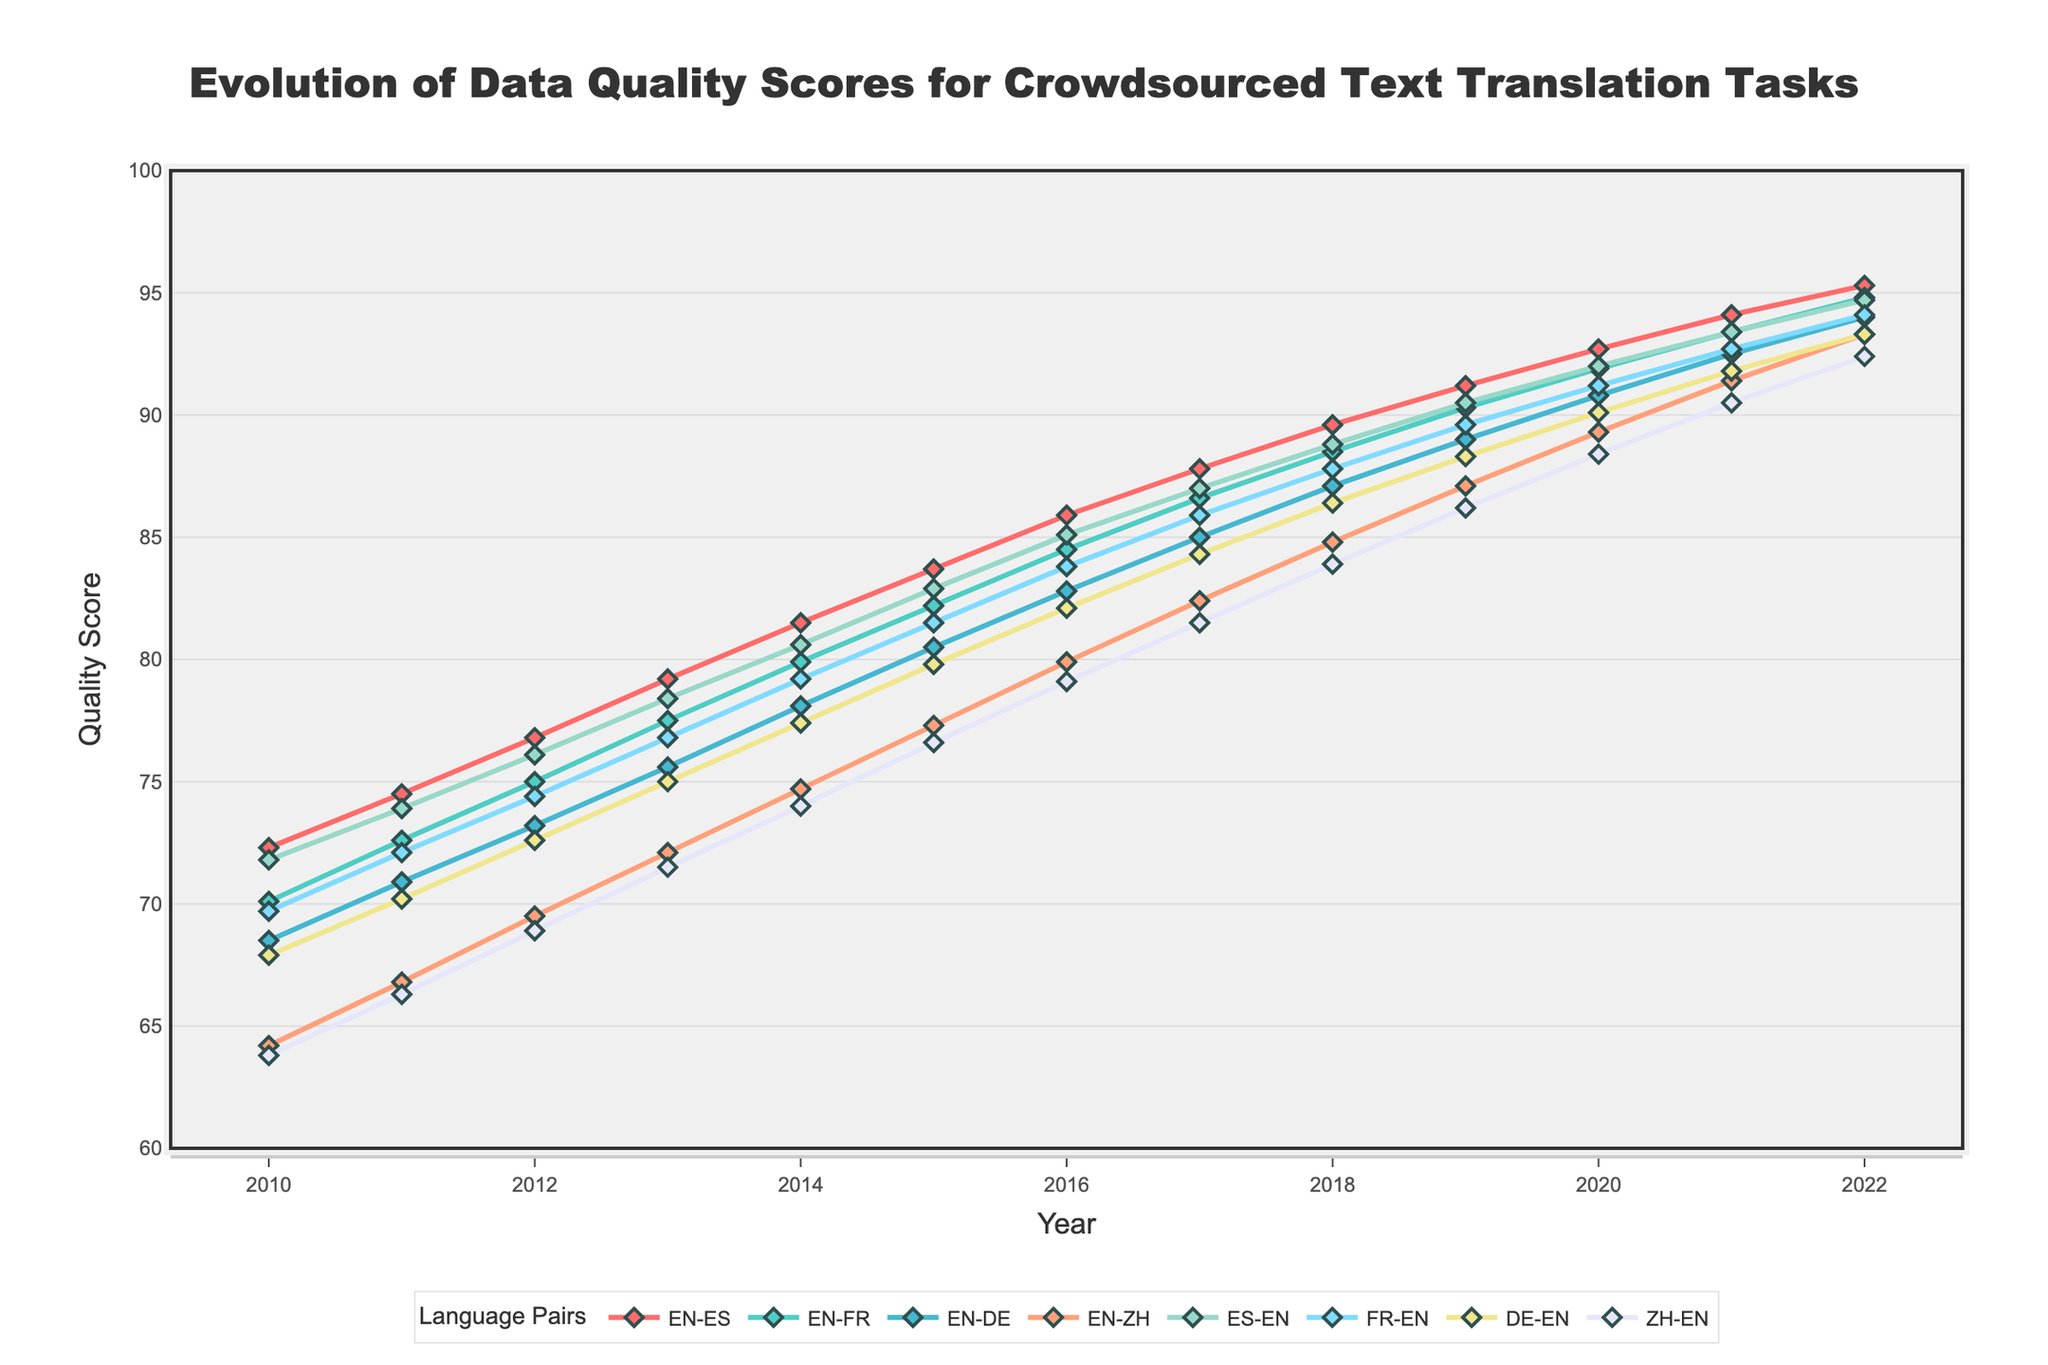What's the overall trend in data quality scores for all language pairs from 2010 to 2022? The data shows a consistent upward trend for all language pairs. This indicates an overall improvement in data quality scores for crowdsourced text translation tasks over the years.
Answer: Upward trend In which year did the EN-DE and EN-FR language pairs have the same quality scores the first time? Looking at the lines representing EN-DE and EN-FR, we see they first have the same quality scores in 2017, both reaching a score close to 85.
Answer: 2017 Which language pair consistently had the highest quality score from 2010 to 2022? Observing the trend lines, the EN-ES language pair consistently had the highest quality scores compared to other language pairs in each year.
Answer: EN-ES What is the difference in quality scores for the EN-ZH language pair from 2010 to 2022? In 2010, the EN-ZH pair had a quality score of 64.2, and in 2022, it had a score of 93.3. The difference is 93.3 - 64.2 = 29.1.
Answer: 29.1 How do the quality scores for ES-EN and FR-EN compare in 2020? In 2020, the quality score for ES-EN is 92.0, whereas for FR-EN, it is 91.2. ES-EN is slightly higher by 0.8 points.
Answer: ES-EN is higher by 0.8 Which language pair experienced the greatest increase in quality score from 2010 to 2022? Calculating the differences from 2010 to 2022, EN-ZH had the greatest increase: 93.3 (2022) - 64.2 (2010) = 29.1. Other pairs show smaller increases.
Answer: EN-ZH By how many points did the quality score for the EN-FR language pair improve from 2011 to 2013? The quality score for EN-FR in 2011 was 72.6 and in 2013 was 77.5. The improvement is 77.5 - 72.6 = 4.9 points.
Answer: 4.9 What is the average quality score for the EN-ES language pair over the given period? Summing the EN-ES quality scores from 2010 to 2022 and dividing by the number of years gives (72.3 + 74.5 + 76.8 + 79.2 + 81.5 + 83.7 + 85.9 + 87.8 + 89.6 + 91.2 + 92.7 + 94.1 + 95.3) / 13 ≈ 84.4.
Answer: Approximately 84.4 What can you say about the quality scores for DE-EN from 2010 to 2022? The quality scores for DE-EN show a steady increase from 67.9 in 2010 to 93.3 in 2022, indicating continuous improvement.
Answer: Steady increase Which language pair had the lowest quality score in 2012, and what was that score? Observing the lines and points for the year 2012, EN-ZH had the lowest quality score at 69.5.
Answer: EN-ZH with 69.5 